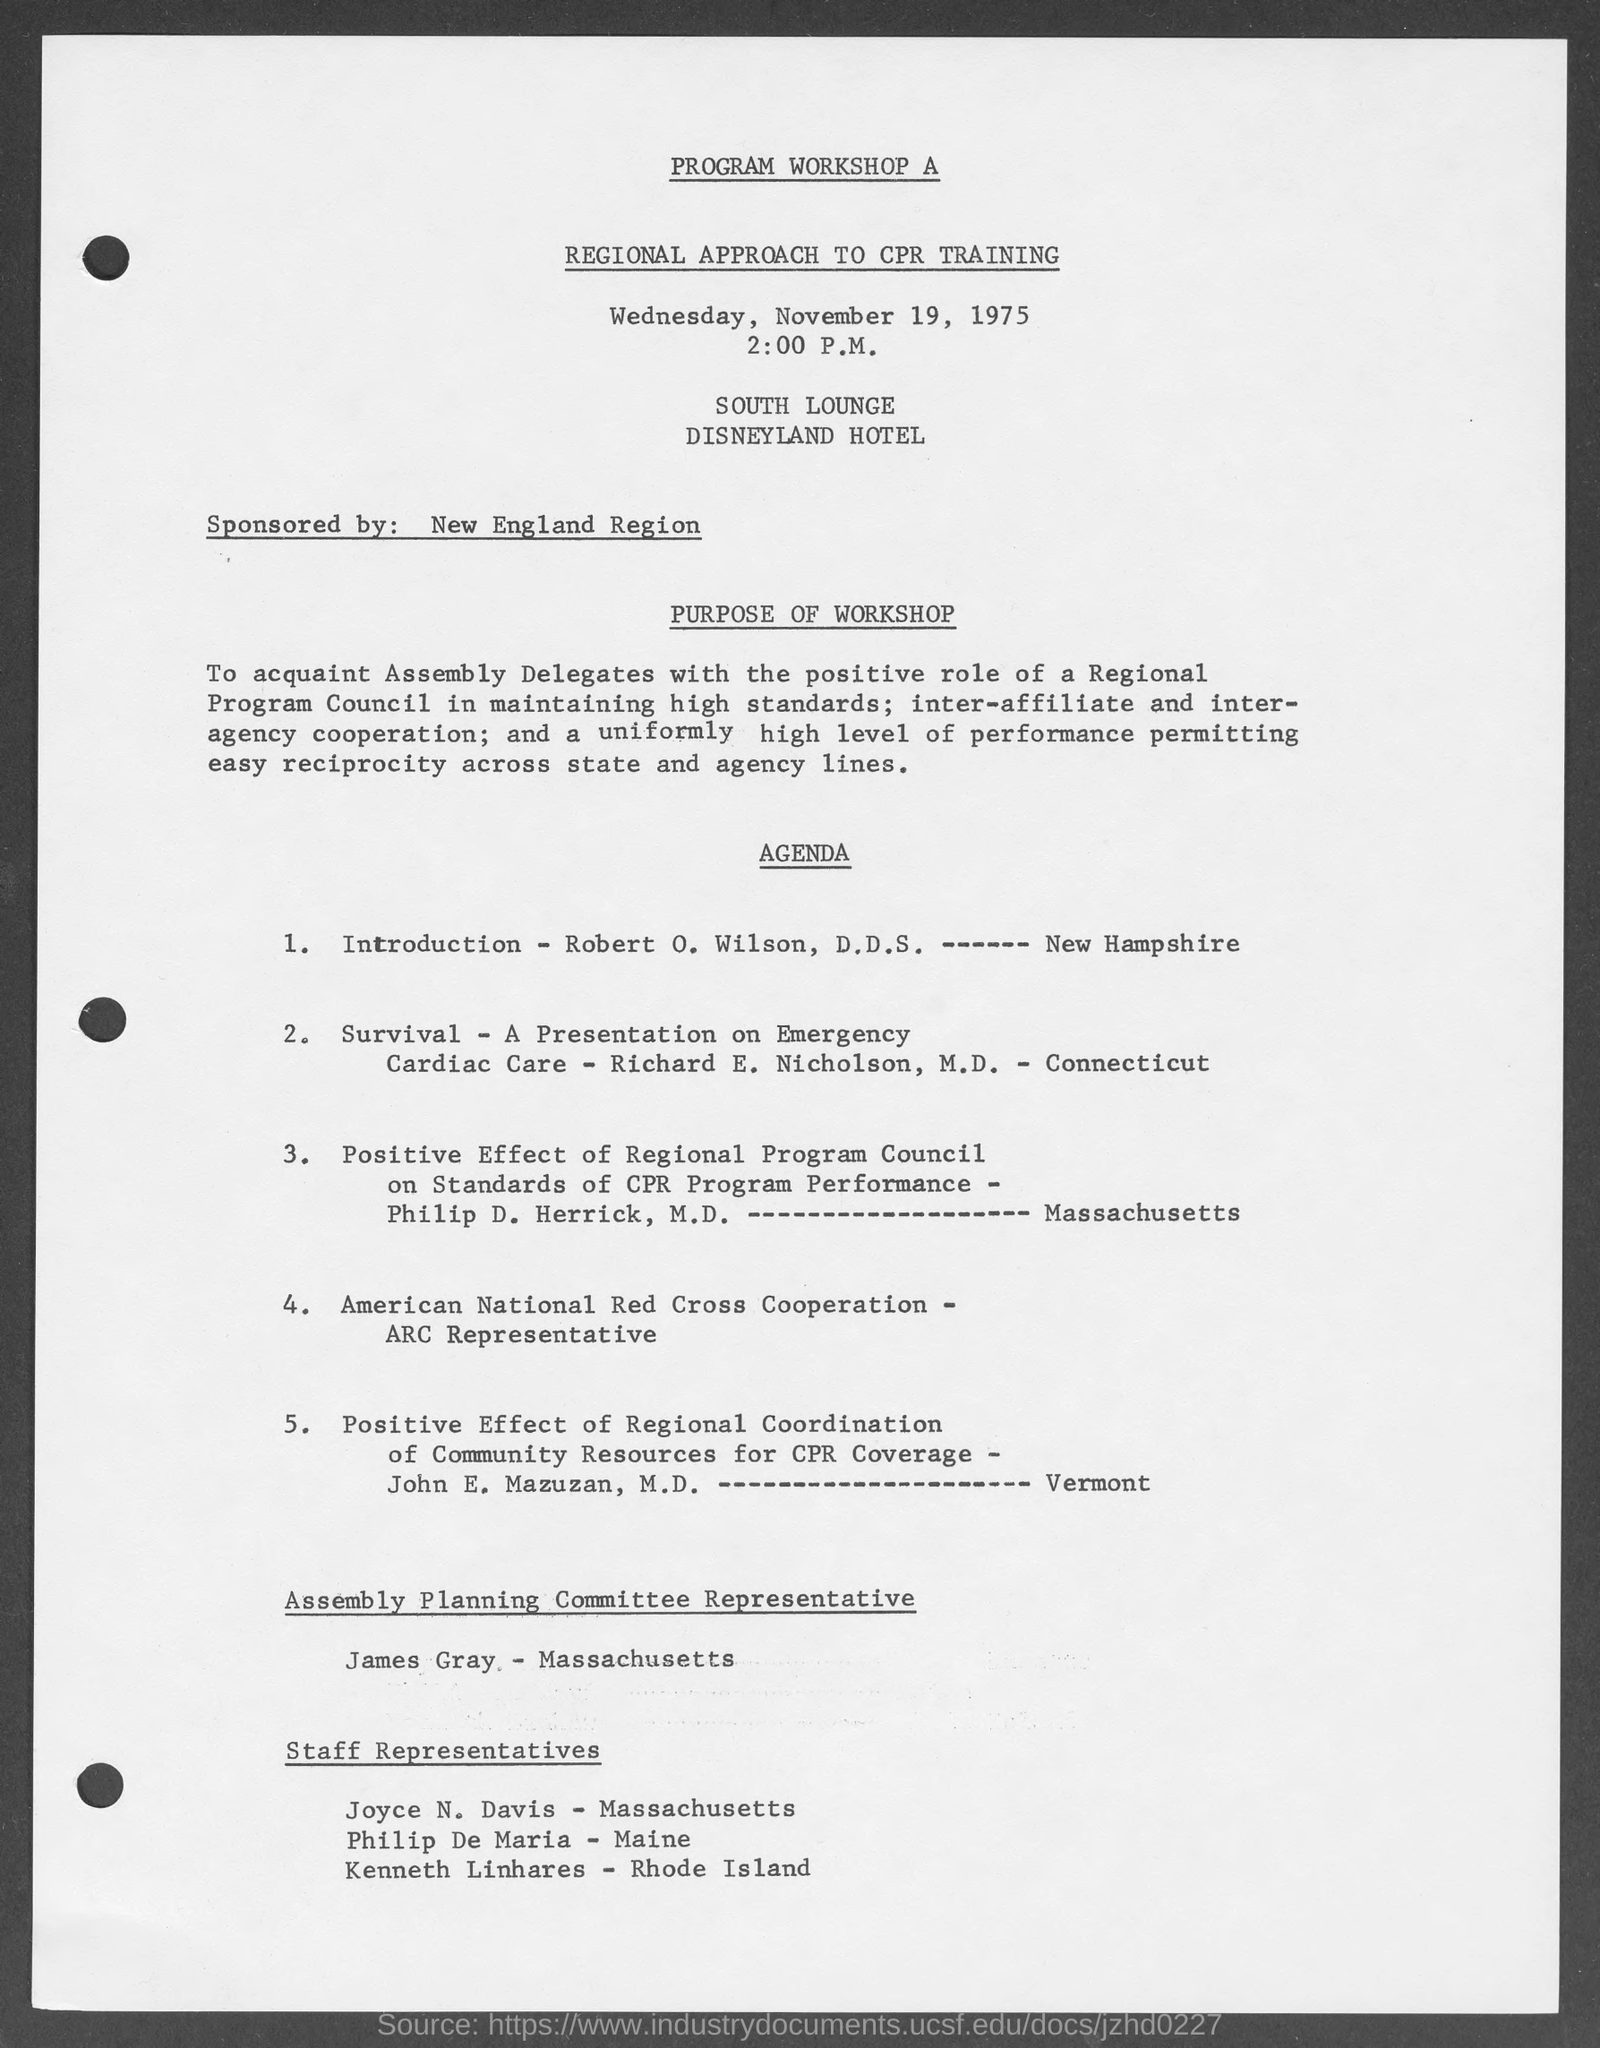Where is the Workshop organized?
Ensure brevity in your answer.  SOUTH LOUNGE DISNEYLAND HOTEL. Who is the Assembly Planning Committee Representative as per the agenda?
Offer a terse response. James Gray. 